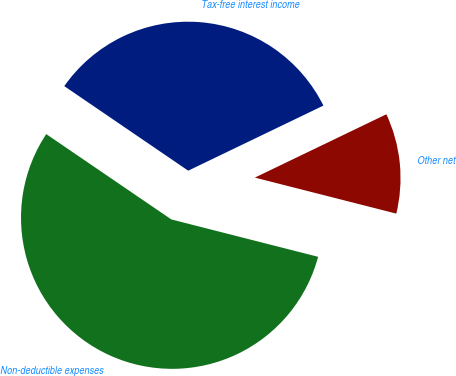Convert chart to OTSL. <chart><loc_0><loc_0><loc_500><loc_500><pie_chart><fcel>Tax-free interest income<fcel>Non-deductible expenses<fcel>Other net<nl><fcel>33.33%<fcel>55.56%<fcel>11.11%<nl></chart> 